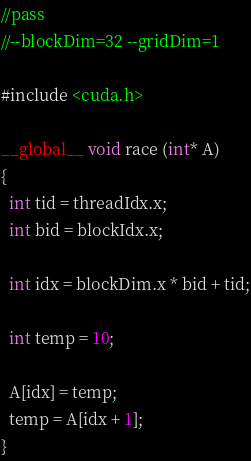<code> <loc_0><loc_0><loc_500><loc_500><_Cuda_>//pass
//--blockDim=32 --gridDim=1

#include <cuda.h>

__global__ void race (int* A)
{
  int tid = threadIdx.x;
  int bid = blockIdx.x;

  int idx = blockDim.x * bid + tid;

  int temp = 10;

  A[idx] = temp;
  temp = A[idx + 1];
}</code> 